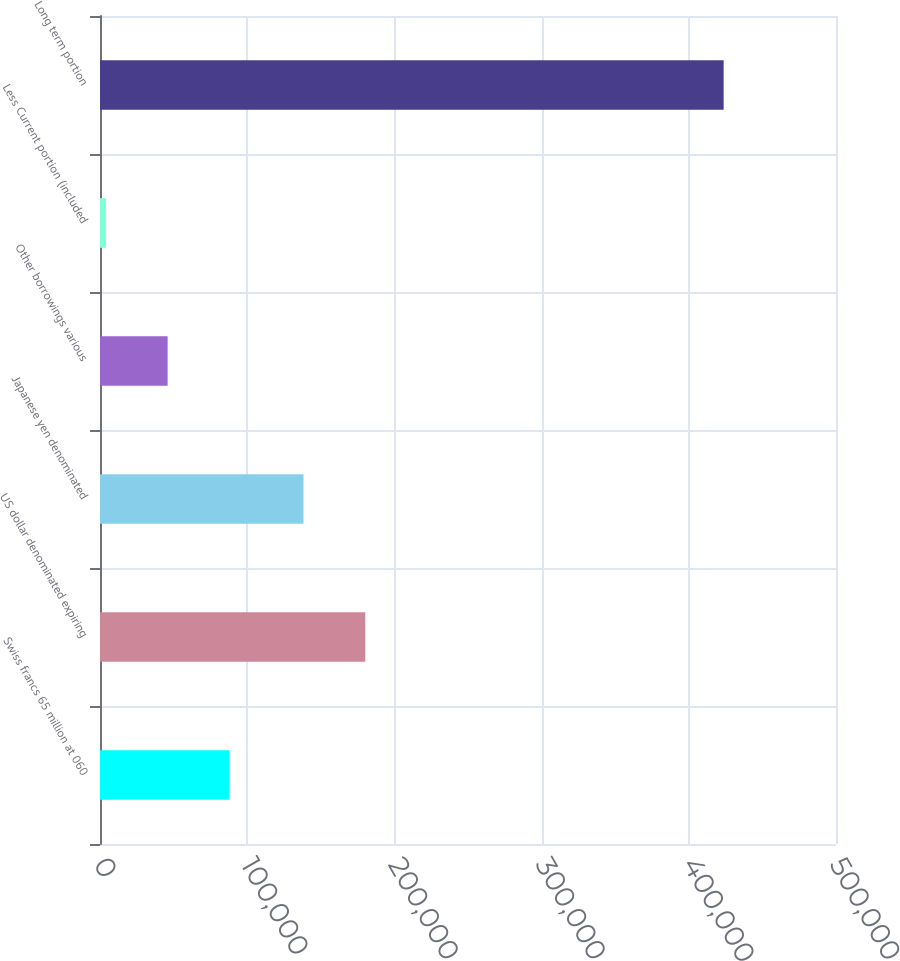Convert chart to OTSL. <chart><loc_0><loc_0><loc_500><loc_500><bar_chart><fcel>Swiss francs 65 million at 060<fcel>US dollar denominated expiring<fcel>Japanese yen denominated<fcel>Other borrowings various<fcel>Less Current portion (included<fcel>Long term portion<nl><fcel>87919.8<fcel>180217<fcel>138247<fcel>45949.9<fcel>3980<fcel>423679<nl></chart> 